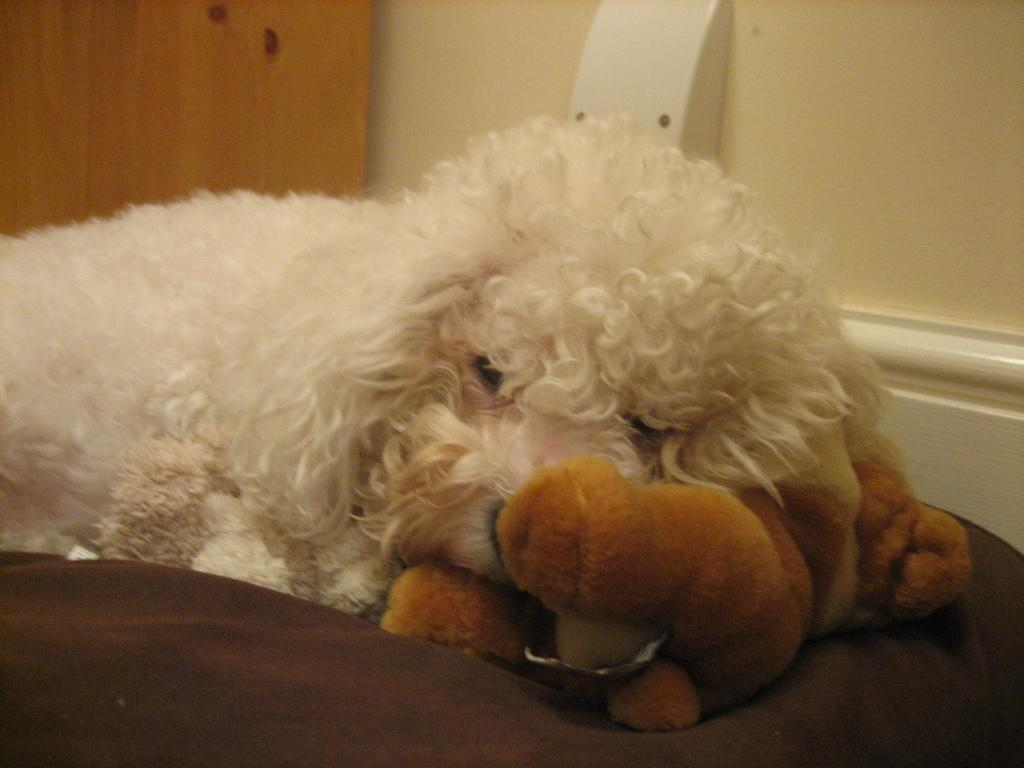What type of animal is in the image? There is a dog in the image. What object is in the front of the image? There is a doll in the front of the image. Where is the dog bed located in the image? The dog bed is at the bottom of the image. What can be seen in the background of the image? There is a door and a wall in the background of the image. How does the dog balance on one paw while holding a stop sign in the image? There is no stop sign present in the image, and the dog is not balancing on one paw. 